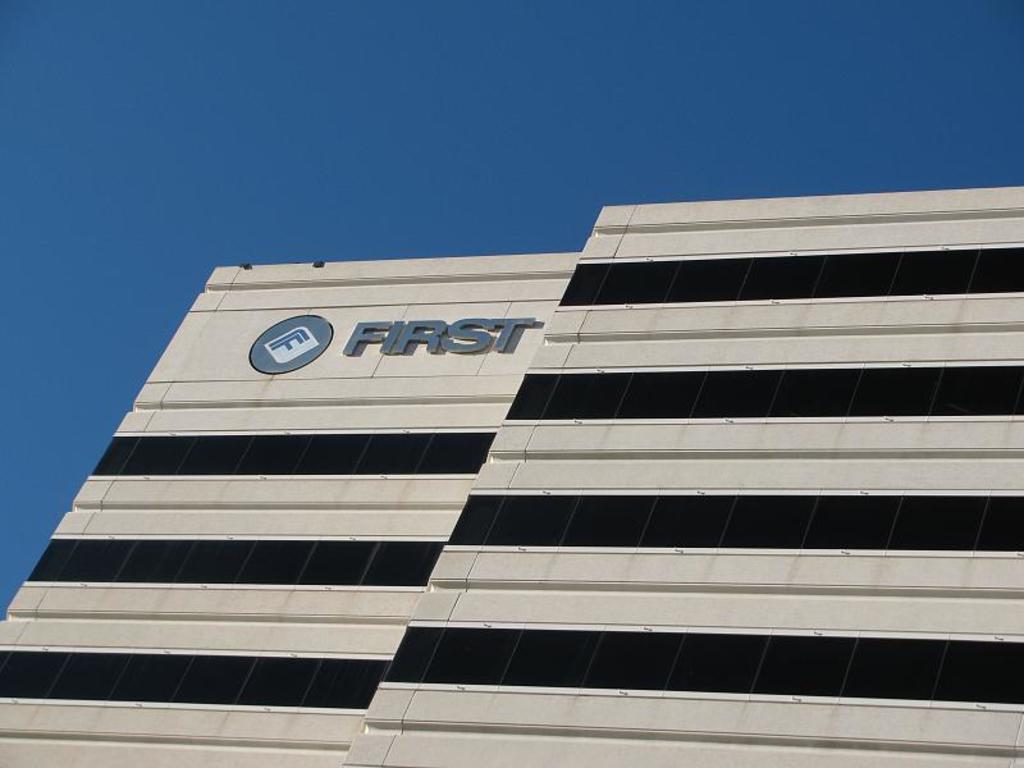Can you describe this image briefly? In this picture we can see a building. 